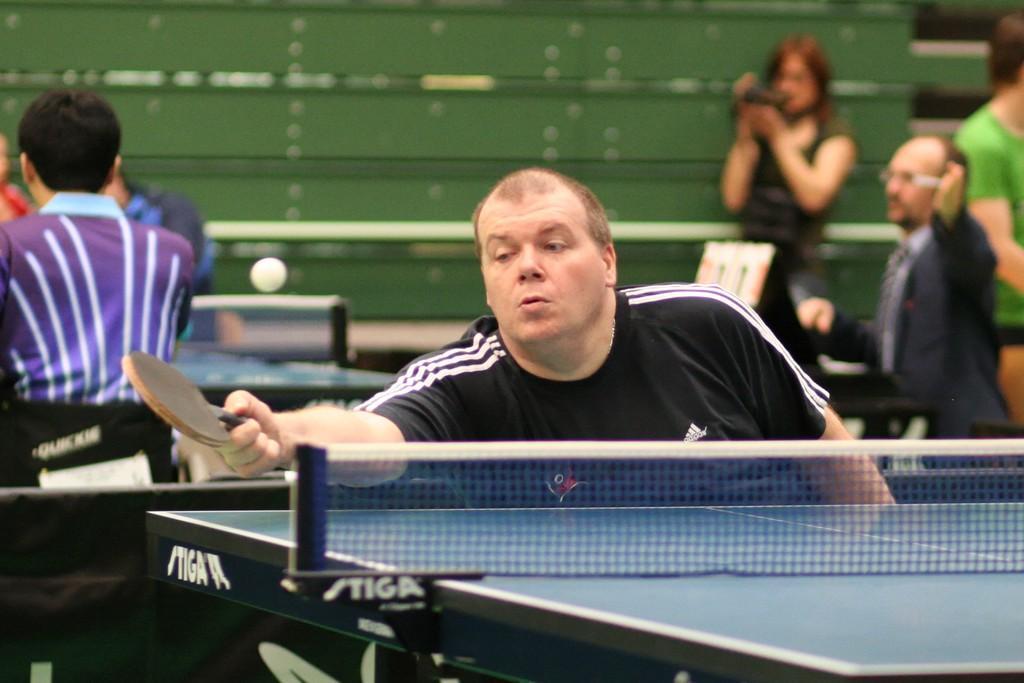How would you summarize this image in a sentence or two? In this picture there is a man who is playing table tennis, he has a bat in his hand and there is a ball over here in the background people, some are practicing and some are audience. 